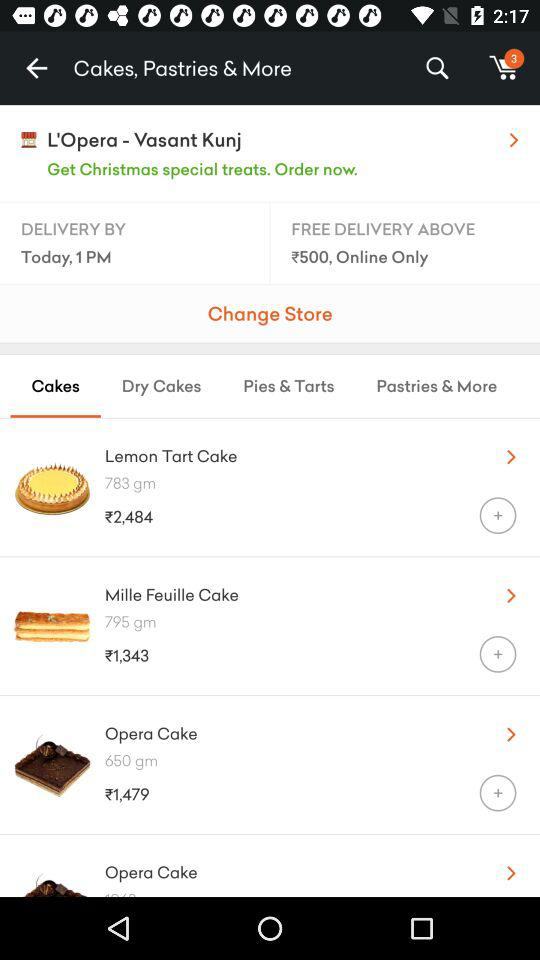What is the day and time given for delivery? Delivery will be done by today, 1 PM. 